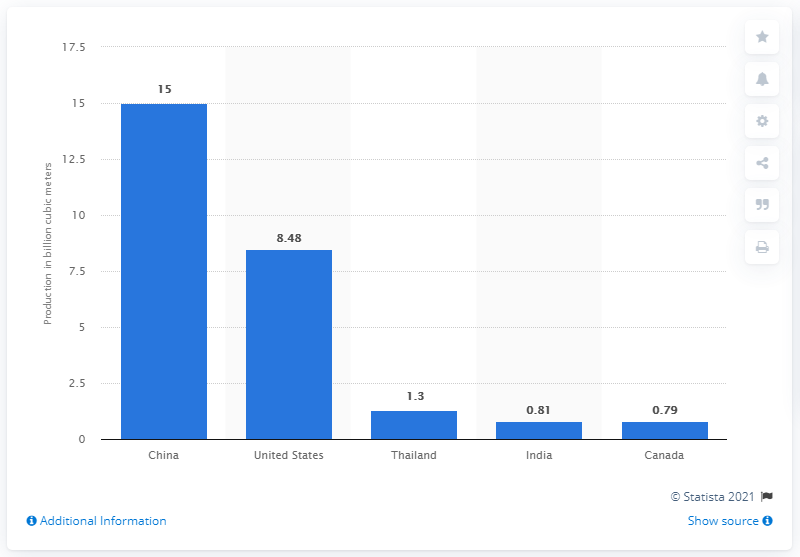List a handful of essential elements in this visual. According to data from 2014, China was the leading producer of biogas in the world. In 2014, China produced 15 million cubic meters of biogas. 